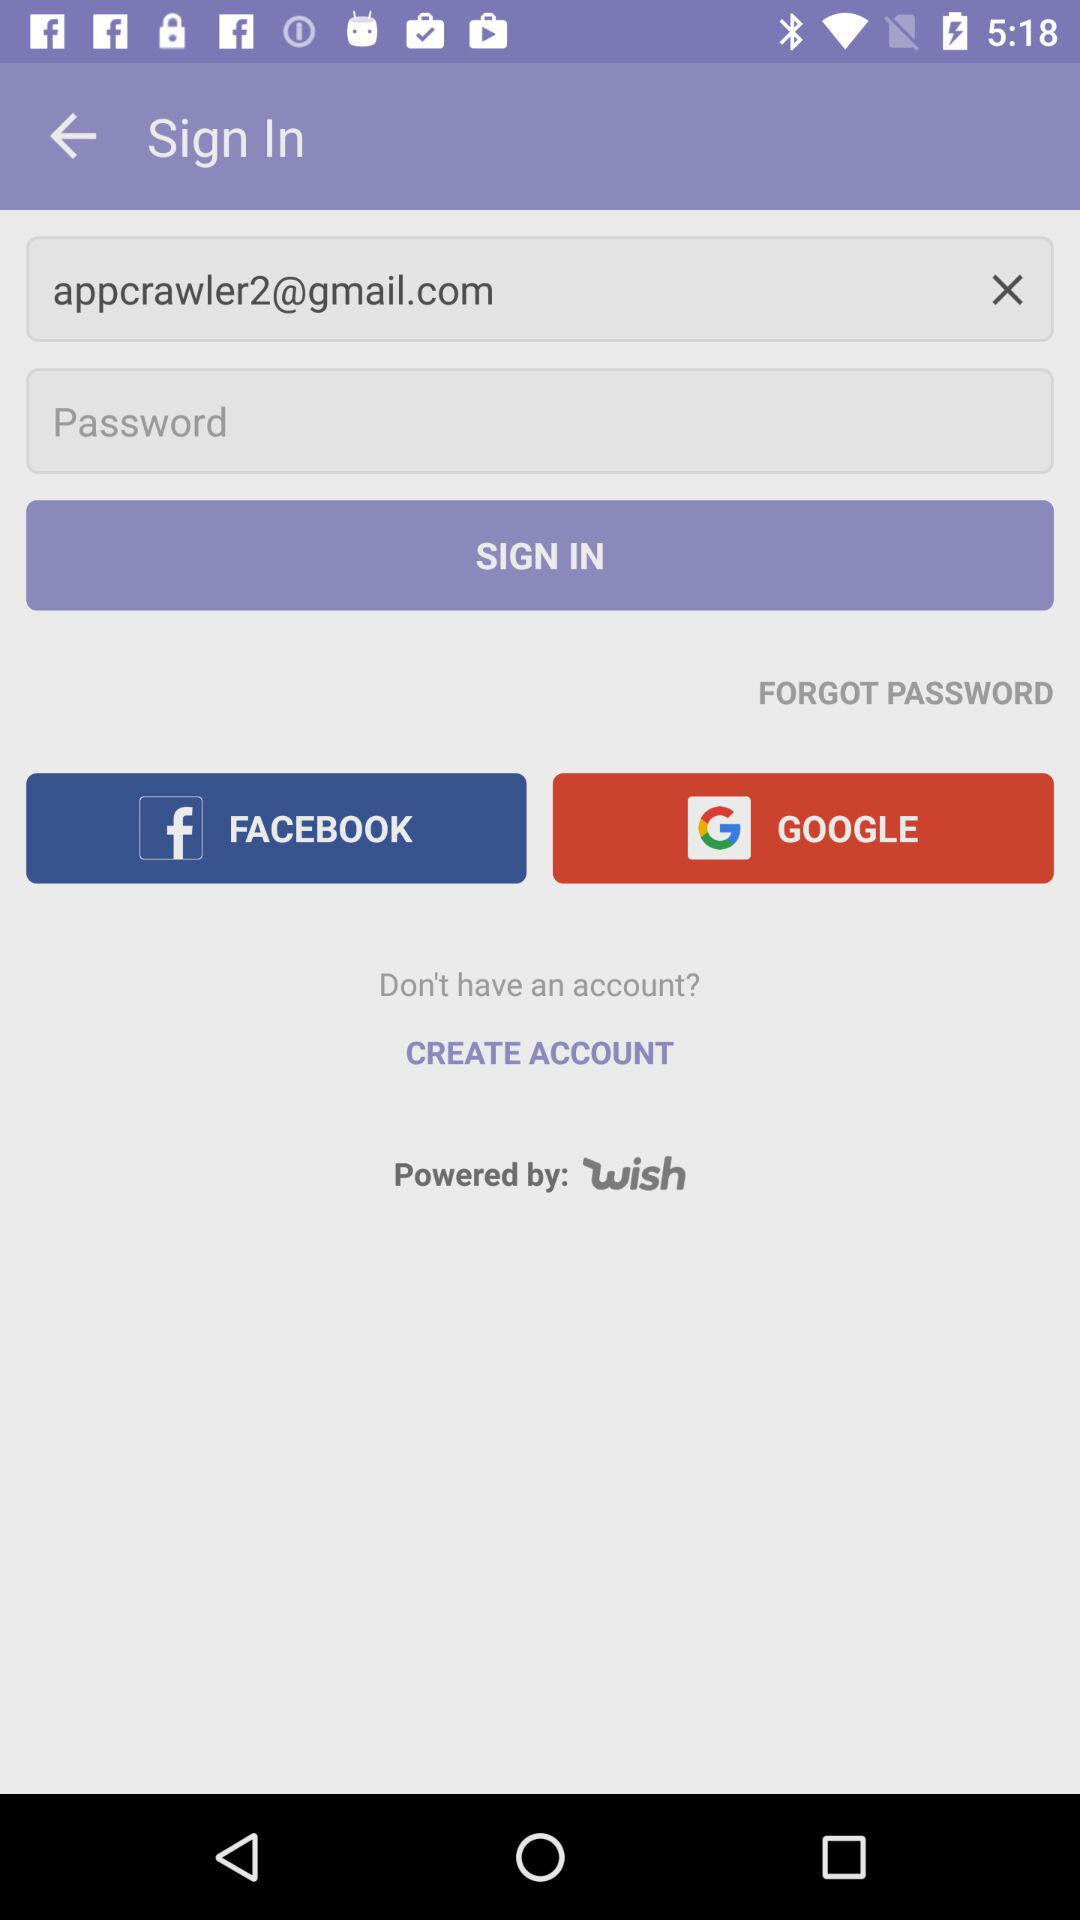How many text inputs are there for logging in?
Answer the question using a single word or phrase. 2 